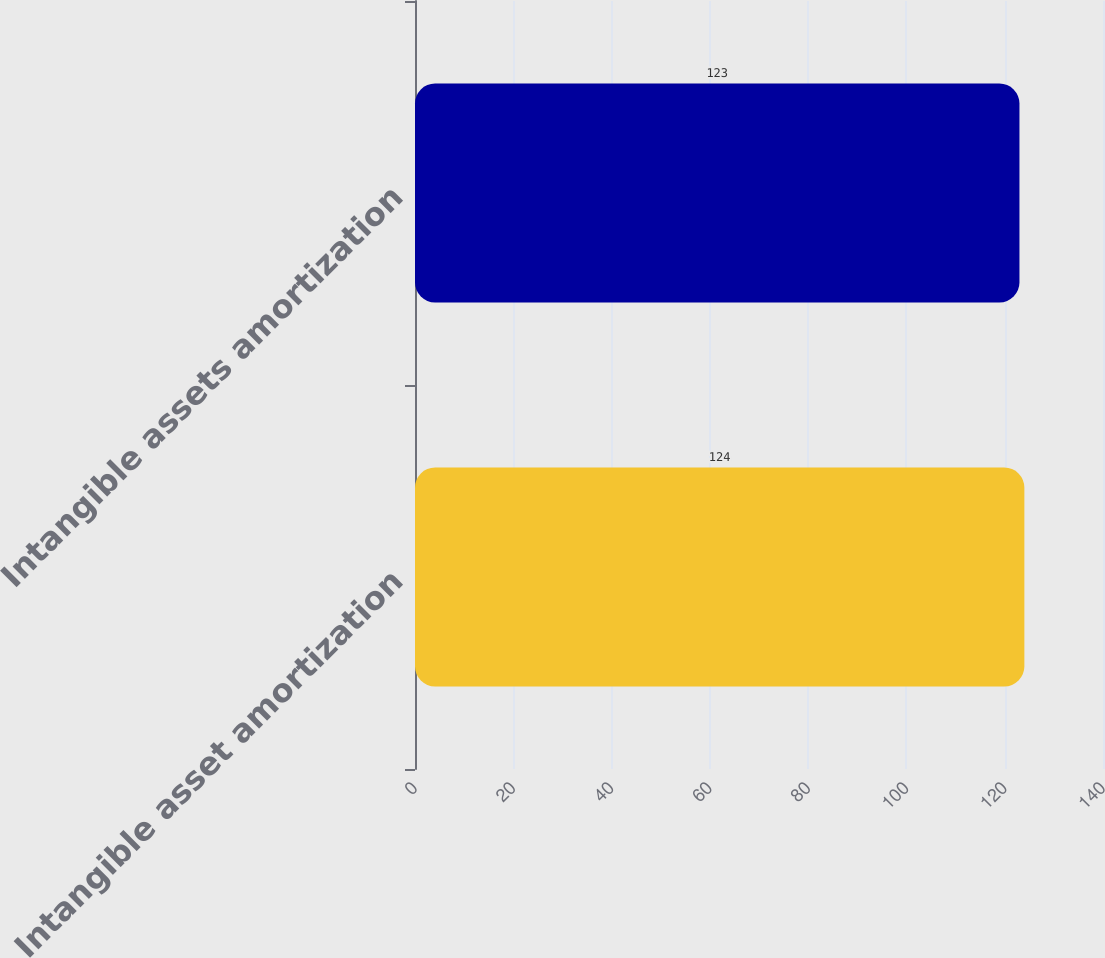Convert chart to OTSL. <chart><loc_0><loc_0><loc_500><loc_500><bar_chart><fcel>Intangible asset amortization<fcel>Intangible assets amortization<nl><fcel>124<fcel>123<nl></chart> 